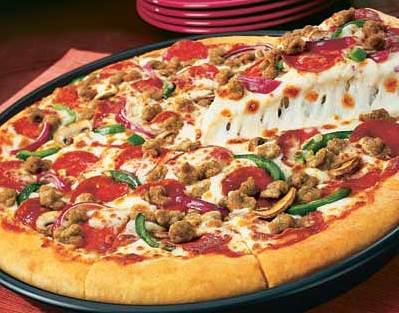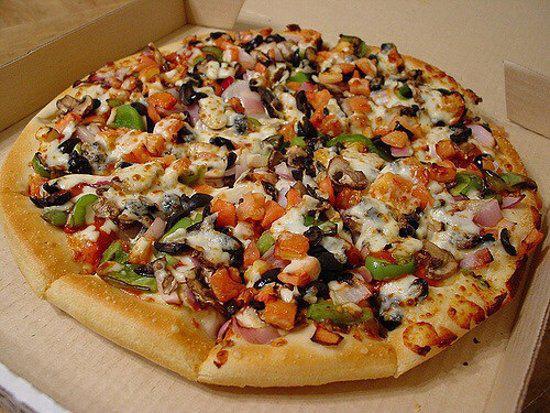The first image is the image on the left, the second image is the image on the right. Given the left and right images, does the statement "One of the pizzas has a single slice lifted with cheese stretching from it, and the other pizza is sliced but has all slices in place." hold true? Answer yes or no. Yes. The first image is the image on the left, the second image is the image on the right. Given the left and right images, does the statement "there is a pizza with a slice being lifted with green peppers on it" hold true? Answer yes or no. Yes. 